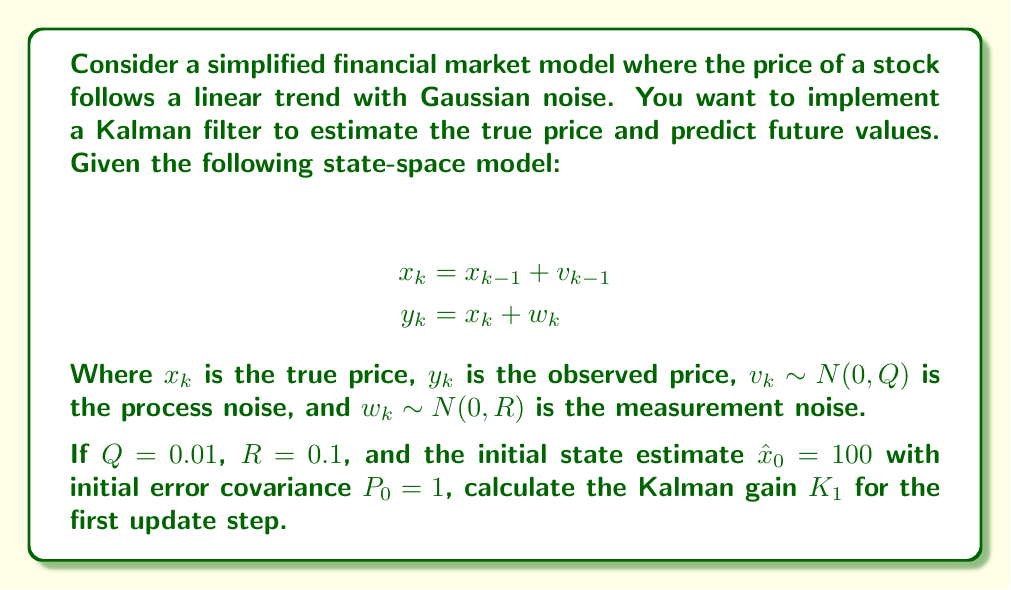Could you help me with this problem? To solve this problem, we'll follow the Kalman filter algorithm steps:

1) First, we need to define our system matrices. In this case:
   $F = 1$ (state transition matrix)
   $H = 1$ (observation matrix)
   $Q = 0.01$ (process noise covariance)
   $R = 0.1$ (measurement noise covariance)

2) Initialize:
   $\hat{x}_0 = 100$
   $P_0 = 1$

3) Predict step:
   $\hat{x}_1^- = F\hat{x}_0 = 1 \cdot 100 = 100$
   $P_1^- = FP_0F^T + Q = 1 \cdot 1 \cdot 1 + 0.01 = 1.01$

4) Update step:
   To calculate the Kalman gain $K_1$, we use the formula:
   $$K_1 = P_1^-H^T(HP_1^-H^T + R)^{-1}$$

   Substituting the values:
   $$K_1 = 1.01 \cdot 1 \cdot (1 \cdot 1.01 \cdot 1 + 0.1)^{-1}$$
   $$K_1 = 1.01 \cdot (1.11)^{-1}$$
   $$K_1 = 1.01 \cdot 0.9009$$
   $$K_1 = 0.9099$$

Thus, the Kalman gain for the first update step is approximately 0.9099.
Answer: $K_1 \approx 0.9099$ 